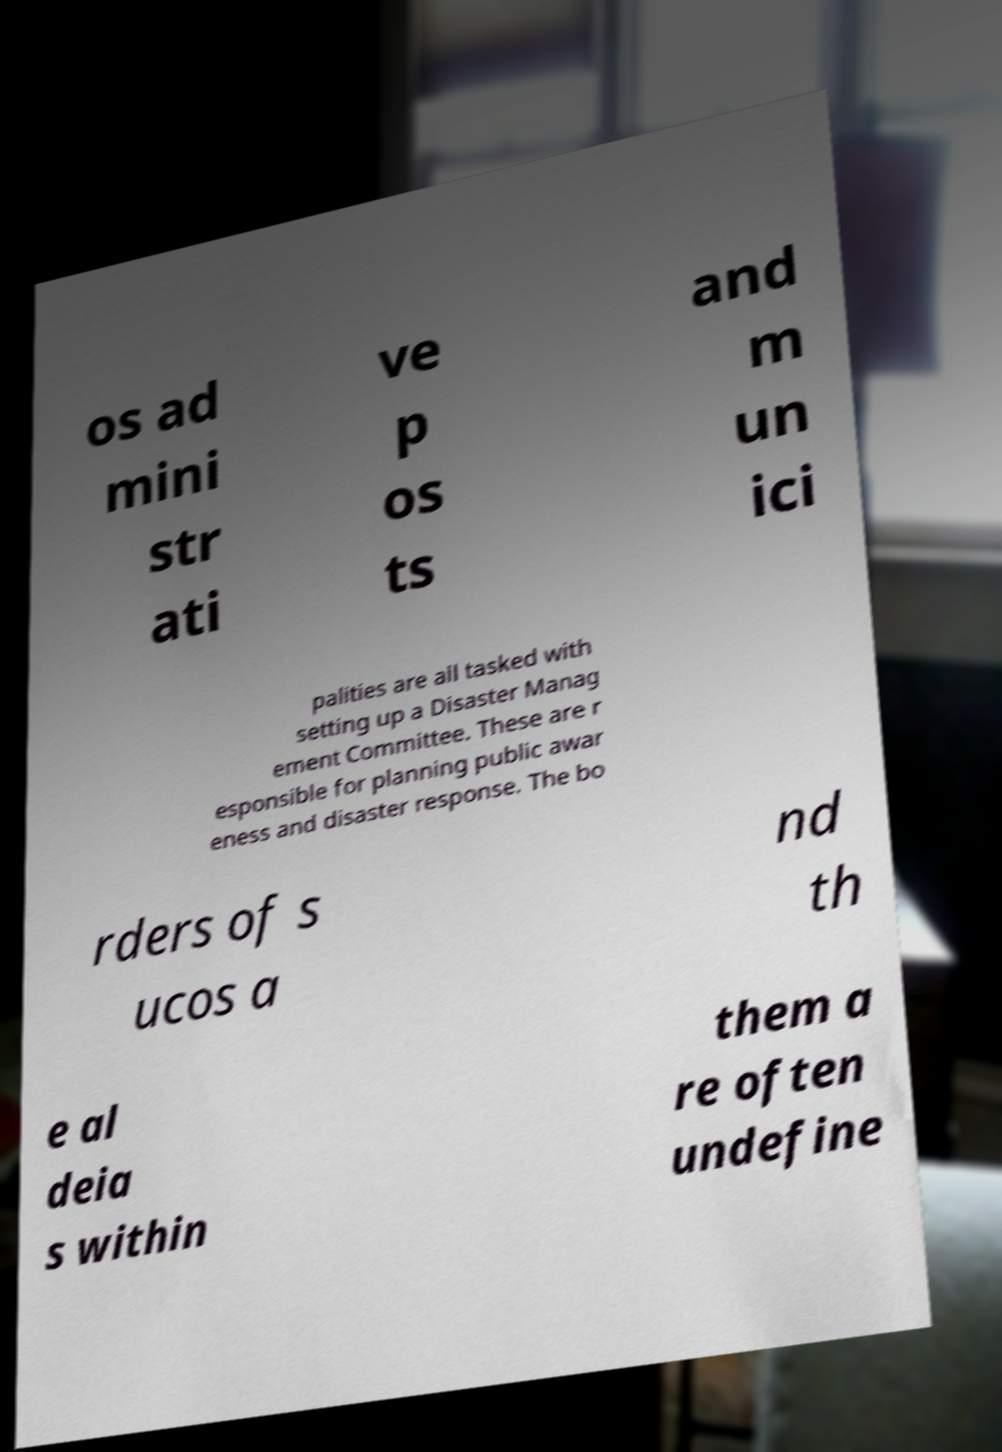There's text embedded in this image that I need extracted. Can you transcribe it verbatim? os ad mini str ati ve p os ts and m un ici palities are all tasked with setting up a Disaster Manag ement Committee. These are r esponsible for planning public awar eness and disaster response. The bo rders of s ucos a nd th e al deia s within them a re often undefine 